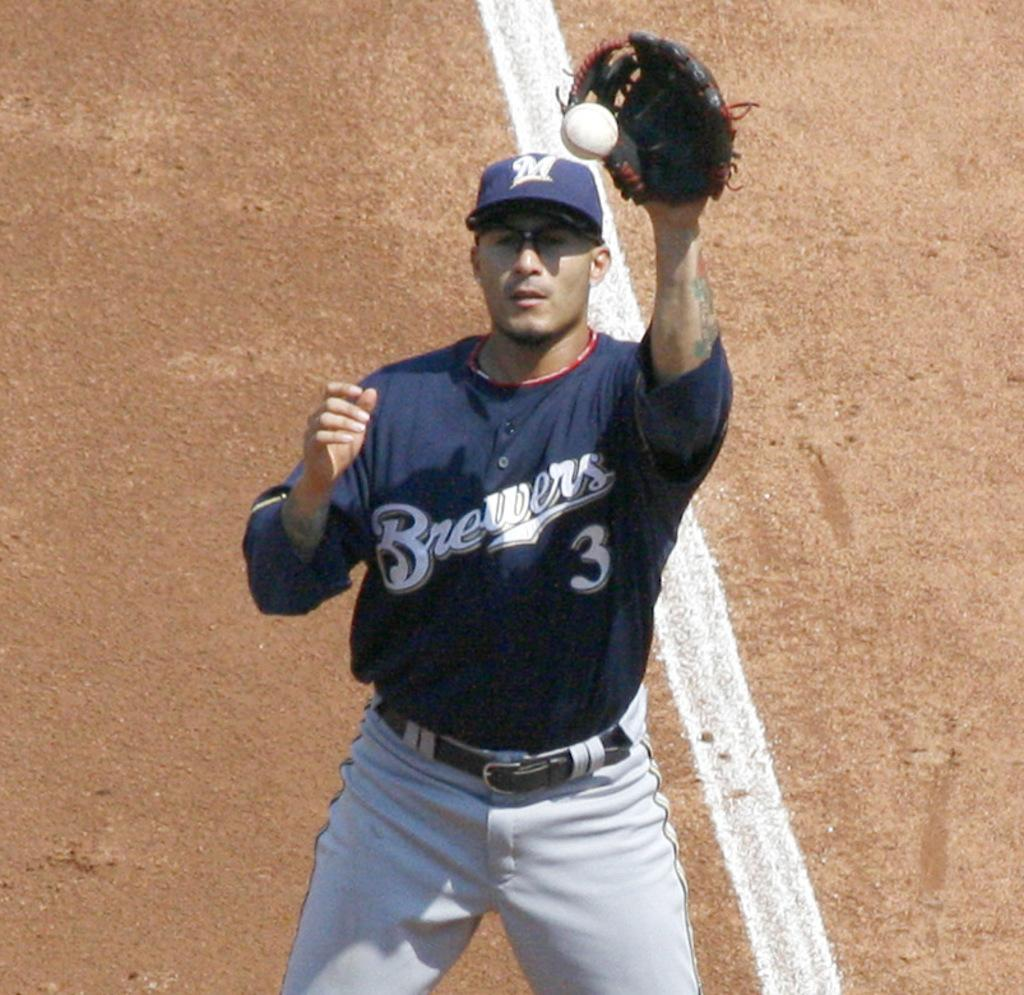Provide a one-sentence caption for the provided image. A Brewers baseball player catching a flying ball. 